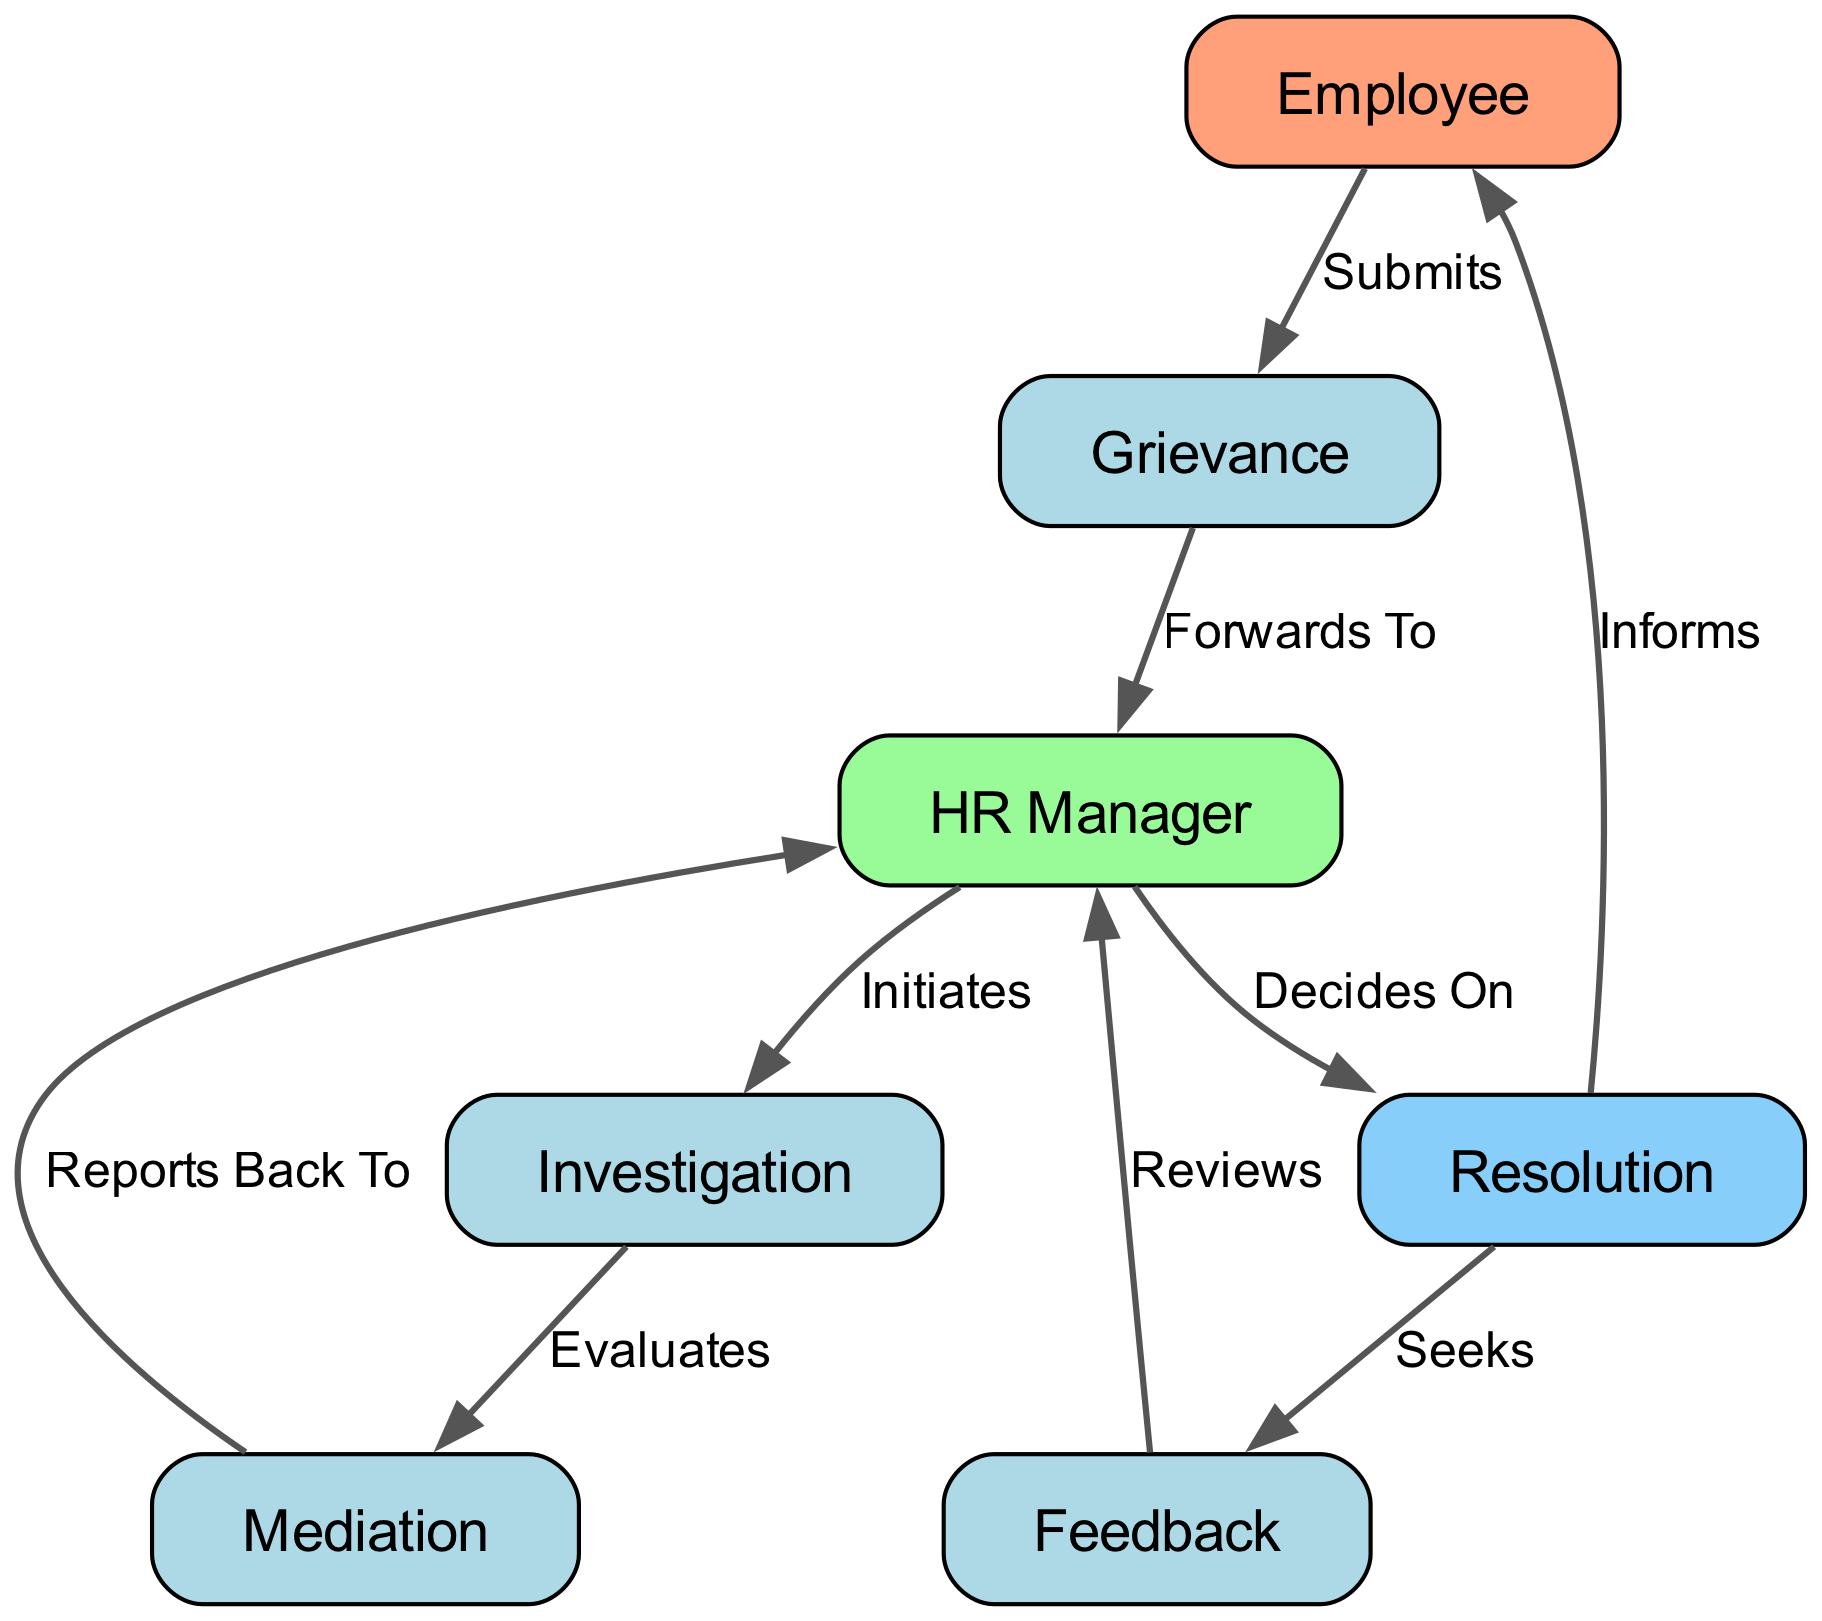What is the starting point of the grievance handling process? The process begins with the Employee node, which represents the employee submitting a grievance.
Answer: Employee How many nodes are present in the diagram? The diagram contains eight nodes, including Employee, Grievance, HR Manager, Investigation, Mediation, Resolution, and Feedback.
Answer: Eight What does the HR Manager do after receiving the grievance? The HR Manager initiates the Investigation process after receiving the grievance.
Answer: Initiates Which node follows Mediation in the grievance process? After the Mediation step, the process goes back to the HR Manager for reporting back, indicating a cyclical flow.
Answer: HR Manager What is sought after the Resolution step? After the Resolution, Feedback is sought, which indicates a step taken for further improvement or evaluation of the process.
Answer: Feedback How many edges represent the flow from the Investigation to the Resolution? There is one edge that connects the Investigation node to the Resolution node, indicating a direct flow from one to the other.
Answer: One What action does the Employee take at the start of the process? The starting action taken by the Employee involves submitting a Grievance to the HR Manager.
Answer: Submits Which step in the process follows the HR Manager's decision on Resolution? After the HR Manager makes a decision on Resolution, the next step is to inform the Employee about the decision made.
Answer: Informs What crucial element does the HR Manager review after feedback is given? The HR Manager reviews the Feedback that was sought after the Resolution phase, which is essential for evaluating the grievance handling process.
Answer: Reviews 